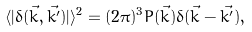<formula> <loc_0><loc_0><loc_500><loc_500>\langle | \delta ( \vec { k } , \vec { k ^ { \prime } } ) | \rangle ^ { 2 } = ( 2 \pi ) ^ { 3 } P ( \vec { k } ) \delta ( \vec { k } - \vec { k ^ { \prime } } ) ,</formula> 